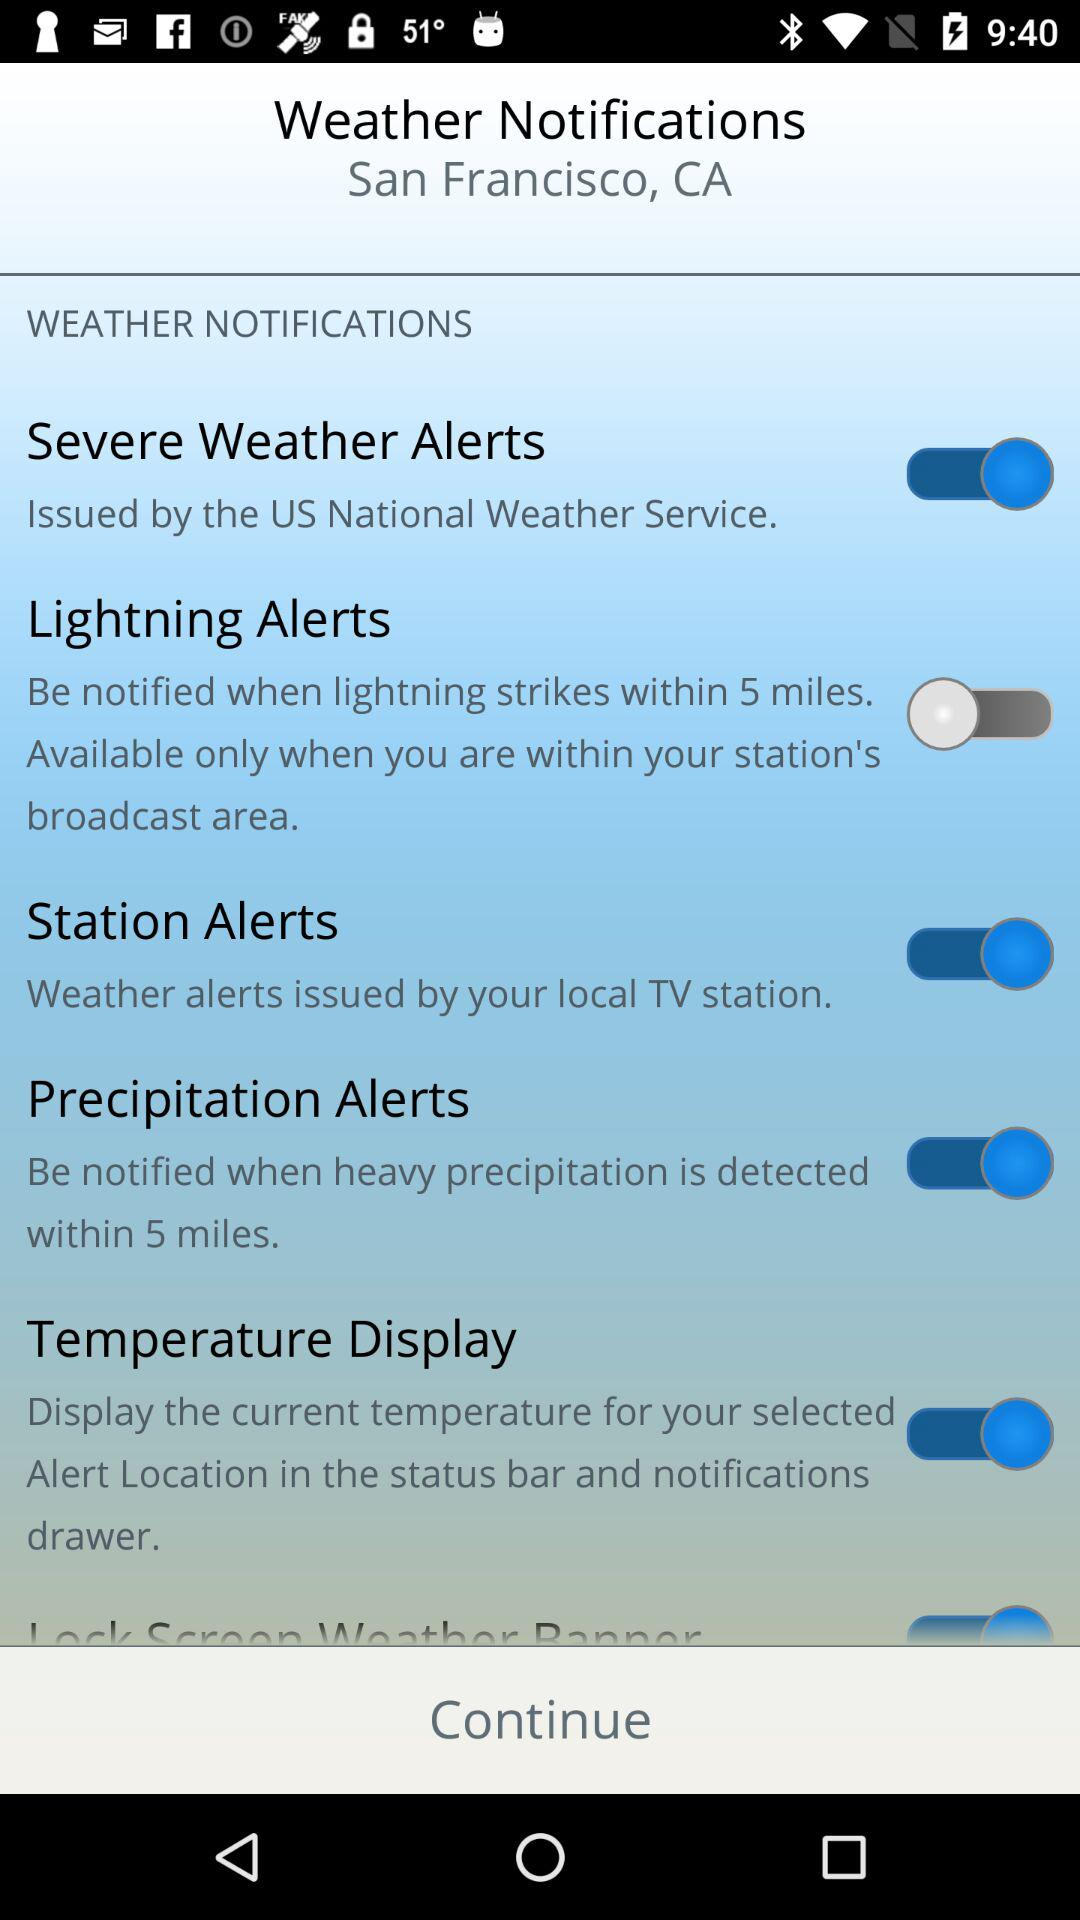For which notifications toggles are switched on? The toggles are switched on for "Severe Weather Alerts", "Station Alerts", "Precipitation Alerts" and "Temperature Display". 